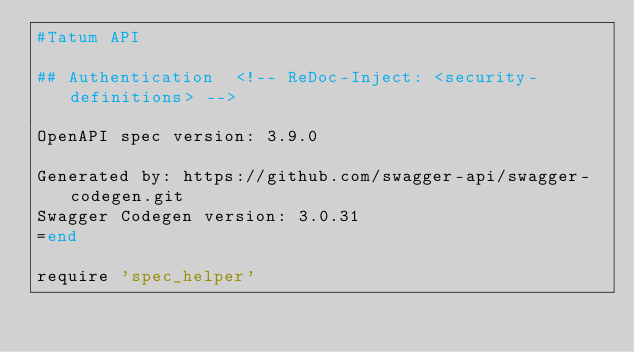Convert code to text. <code><loc_0><loc_0><loc_500><loc_500><_Ruby_>#Tatum API

## Authentication  <!-- ReDoc-Inject: <security-definitions> -->

OpenAPI spec version: 3.9.0

Generated by: https://github.com/swagger-api/swagger-codegen.git
Swagger Codegen version: 3.0.31
=end

require 'spec_helper'</code> 